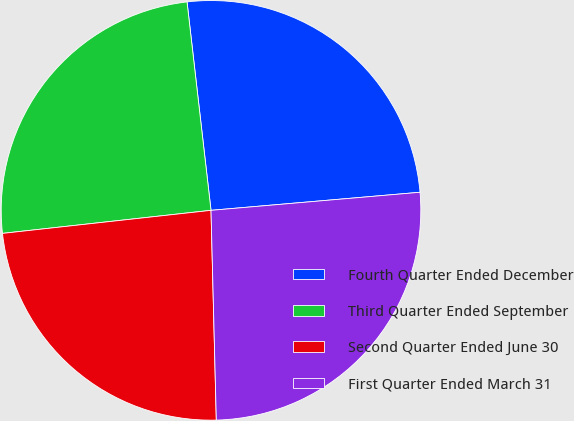Convert chart to OTSL. <chart><loc_0><loc_0><loc_500><loc_500><pie_chart><fcel>Fourth Quarter Ended December<fcel>Third Quarter Ended September<fcel>Second Quarter Ended June 30<fcel>First Quarter Ended March 31<nl><fcel>25.45%<fcel>24.93%<fcel>23.65%<fcel>25.97%<nl></chart> 